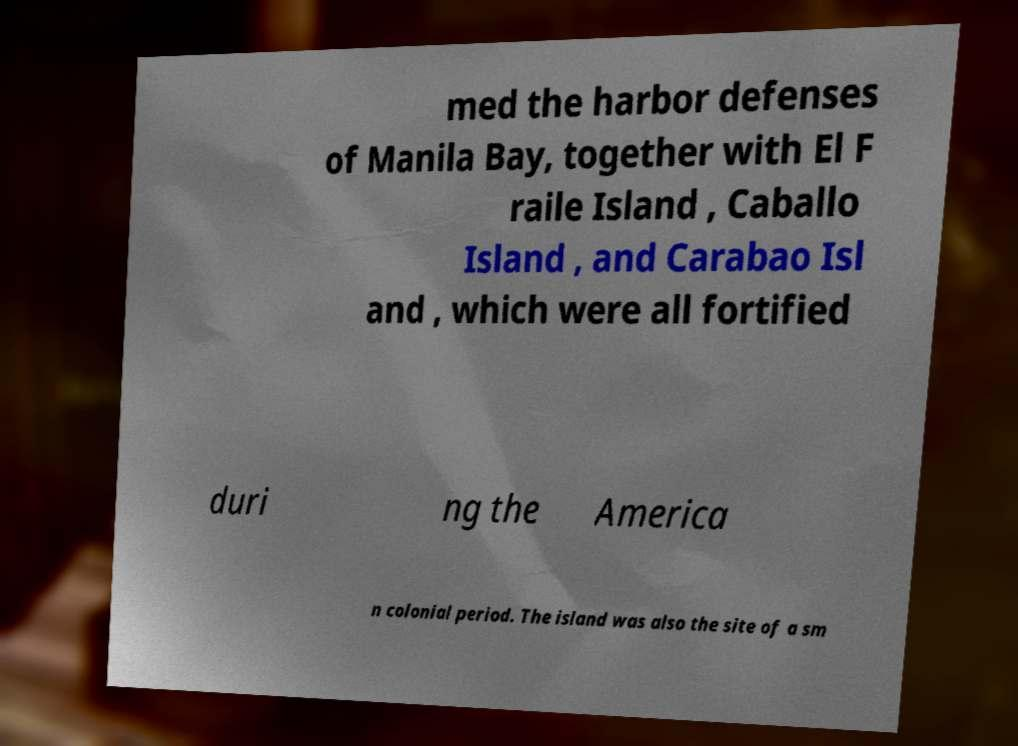There's text embedded in this image that I need extracted. Can you transcribe it verbatim? med the harbor defenses of Manila Bay, together with El F raile Island , Caballo Island , and Carabao Isl and , which were all fortified duri ng the America n colonial period. The island was also the site of a sm 